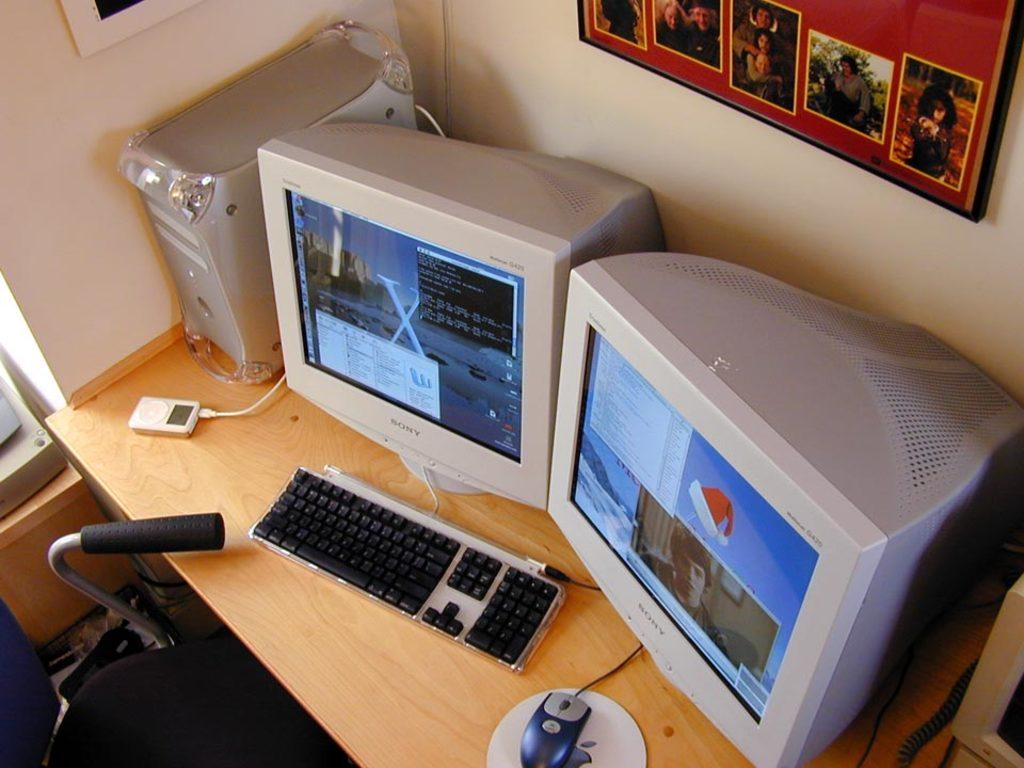What is the main piece of furniture in the image? There is a table in the image. What electronic devices are on the table? There are two monitors, a keyboard, and a mouse on the table. What other object can be seen on the table? There is at least one remote on the table. What is the person sitting on in the image? There is a chair in the image. What can be seen in the background of the image? There is a wall with frames in the background of the image. What type of brass instrument is being played in the image? There is no brass instrument present in the image; it features a table with electronic devices and other objects. 